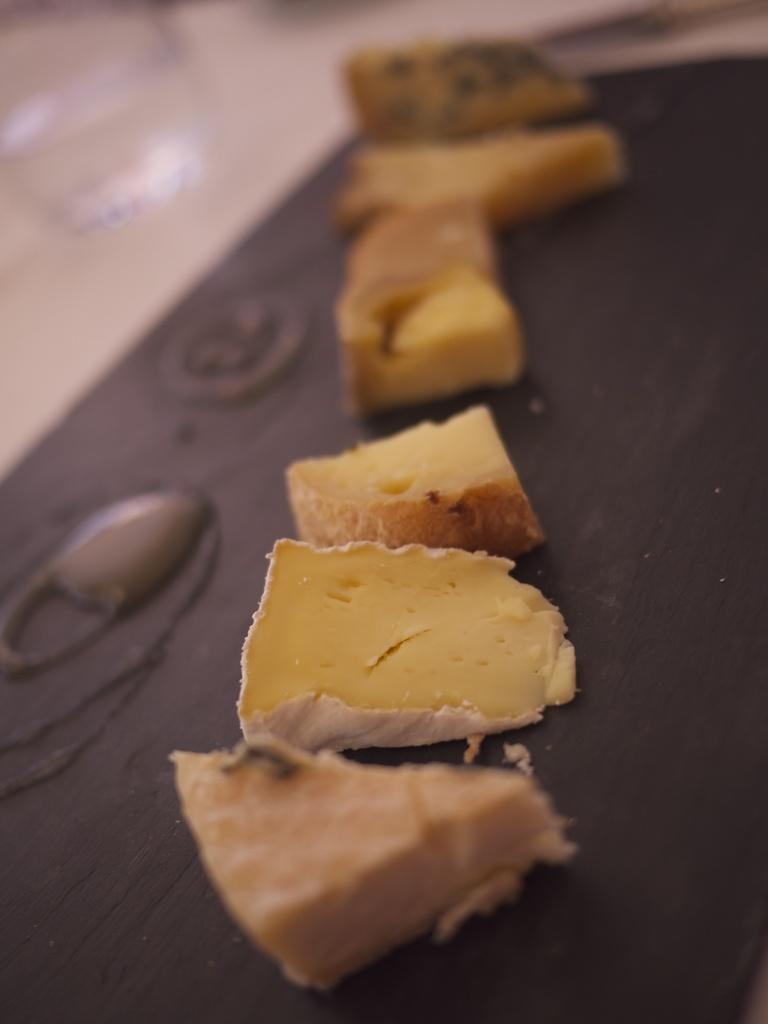How would you summarize this image in a sentence or two? In this image we can see there are cheese slices on the table. 